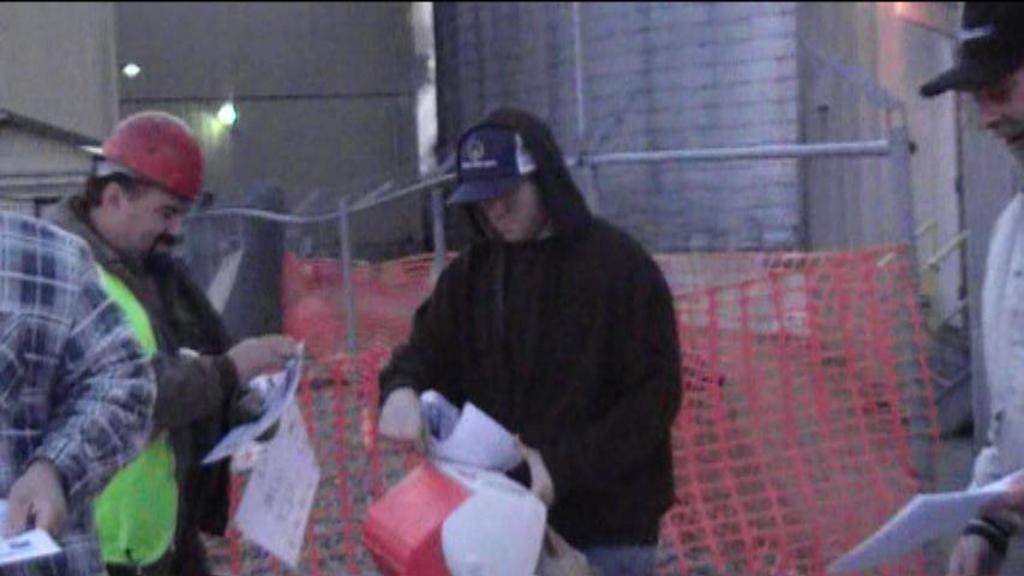In one or two sentences, can you explain what this image depicts? In this picture there are people standing and holding papers and we can see net and rods. In the background of the image we can see wall. 